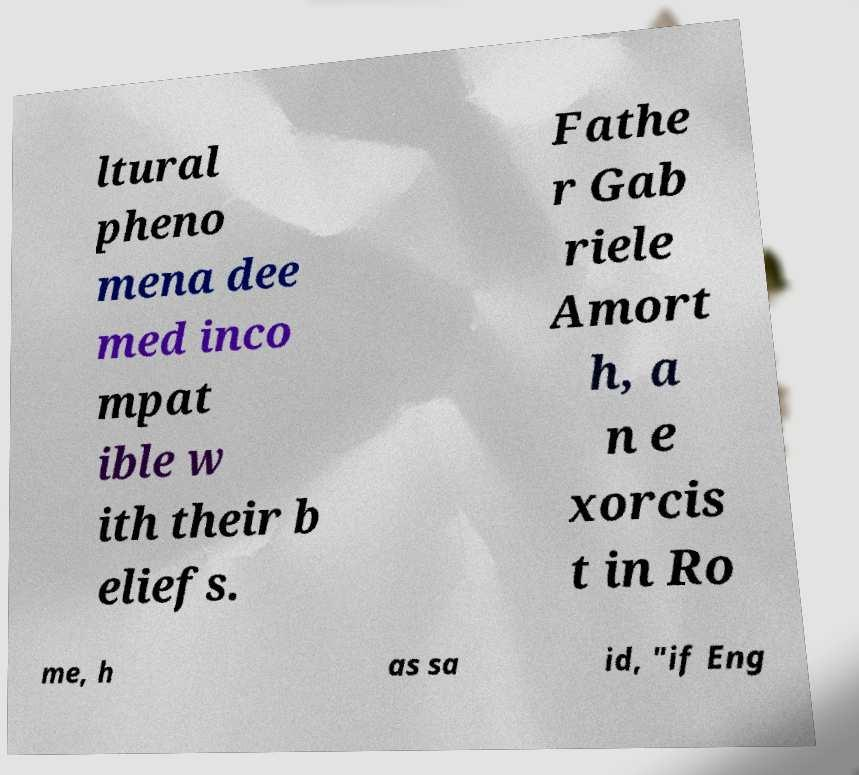Please read and relay the text visible in this image. What does it say? ltural pheno mena dee med inco mpat ible w ith their b eliefs. Fathe r Gab riele Amort h, a n e xorcis t in Ro me, h as sa id, "if Eng 